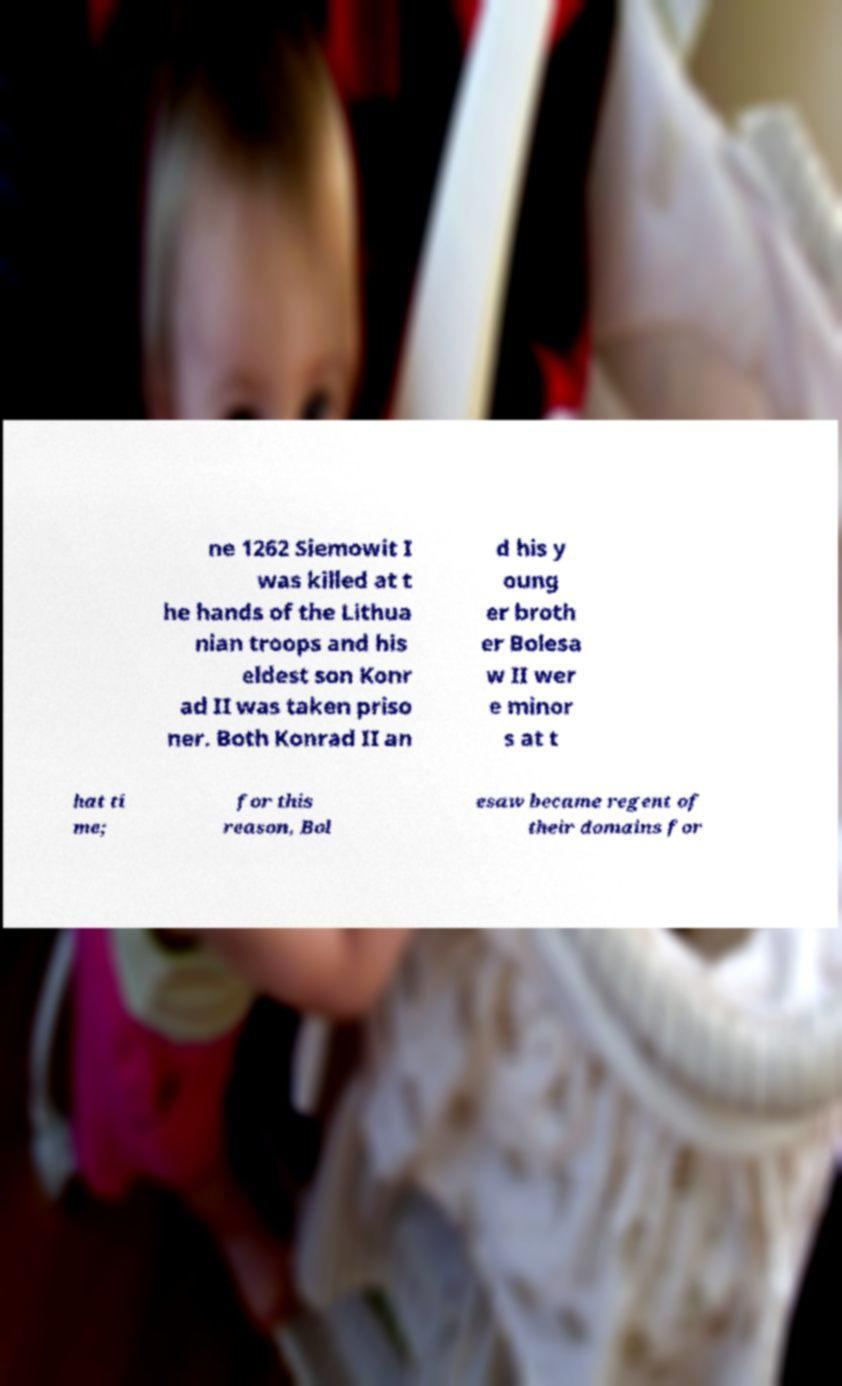For documentation purposes, I need the text within this image transcribed. Could you provide that? ne 1262 Siemowit I was killed at t he hands of the Lithua nian troops and his eldest son Konr ad II was taken priso ner. Both Konrad II an d his y oung er broth er Bolesa w II wer e minor s at t hat ti me; for this reason, Bol esaw became regent of their domains for 